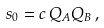<formula> <loc_0><loc_0><loc_500><loc_500>s _ { 0 } = c \, Q _ { A } Q _ { B } \, ,</formula> 